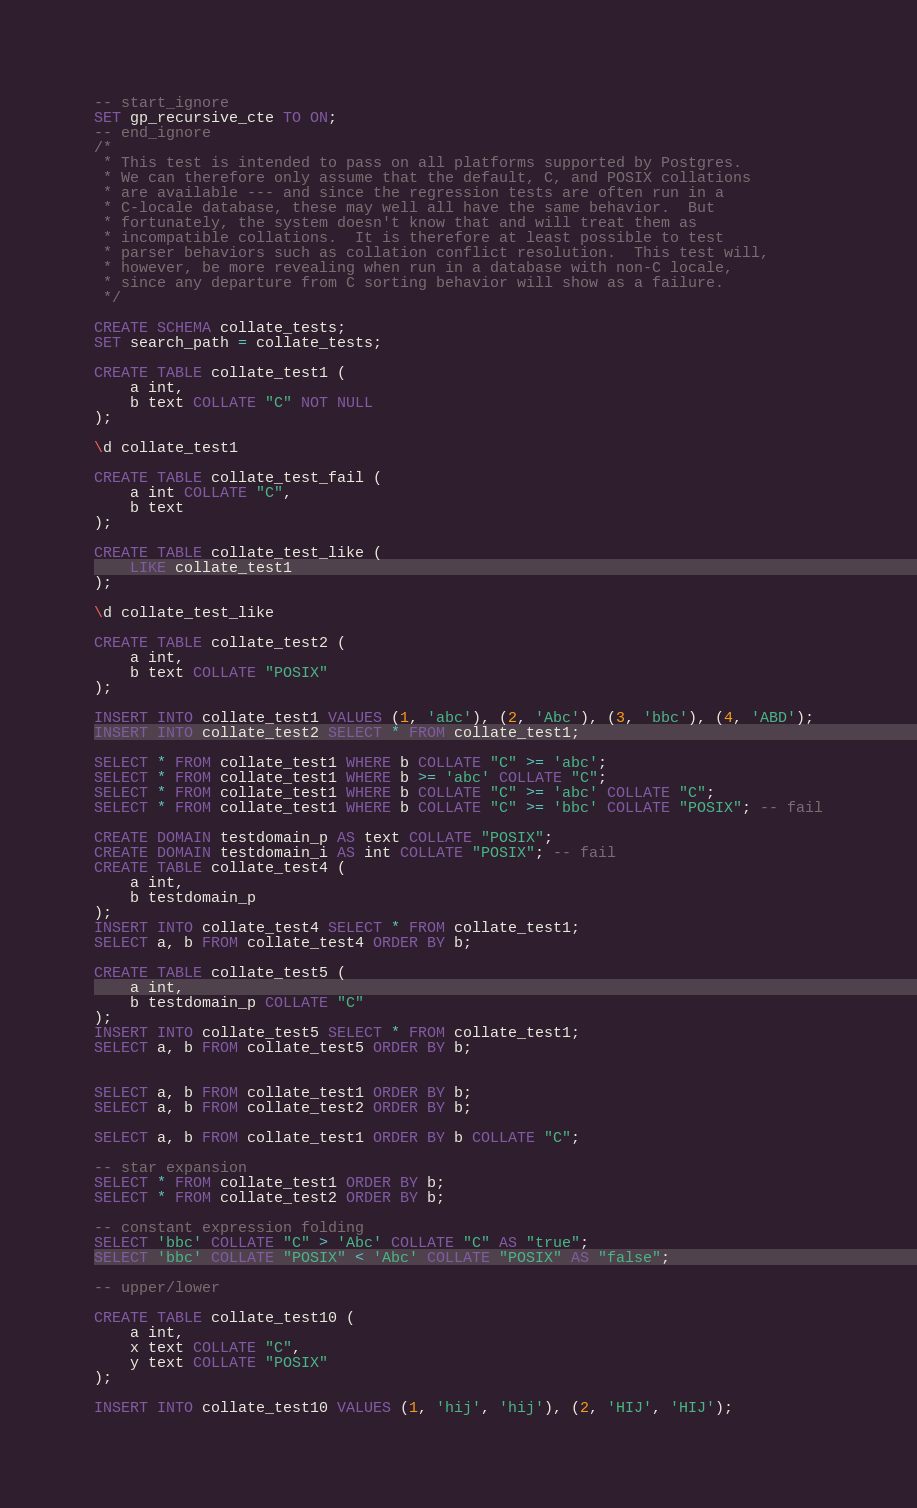<code> <loc_0><loc_0><loc_500><loc_500><_SQL_>-- start_ignore
SET gp_recursive_cte TO ON;
-- end_ignore
/*
 * This test is intended to pass on all platforms supported by Postgres.
 * We can therefore only assume that the default, C, and POSIX collations
 * are available --- and since the regression tests are often run in a
 * C-locale database, these may well all have the same behavior.  But
 * fortunately, the system doesn't know that and will treat them as
 * incompatible collations.  It is therefore at least possible to test
 * parser behaviors such as collation conflict resolution.  This test will,
 * however, be more revealing when run in a database with non-C locale,
 * since any departure from C sorting behavior will show as a failure.
 */

CREATE SCHEMA collate_tests;
SET search_path = collate_tests;

CREATE TABLE collate_test1 (
    a int,
    b text COLLATE "C" NOT NULL
);

\d collate_test1

CREATE TABLE collate_test_fail (
    a int COLLATE "C",
    b text
);

CREATE TABLE collate_test_like (
    LIKE collate_test1
);

\d collate_test_like

CREATE TABLE collate_test2 (
    a int,
    b text COLLATE "POSIX"
);

INSERT INTO collate_test1 VALUES (1, 'abc'), (2, 'Abc'), (3, 'bbc'), (4, 'ABD');
INSERT INTO collate_test2 SELECT * FROM collate_test1;

SELECT * FROM collate_test1 WHERE b COLLATE "C" >= 'abc';
SELECT * FROM collate_test1 WHERE b >= 'abc' COLLATE "C";
SELECT * FROM collate_test1 WHERE b COLLATE "C" >= 'abc' COLLATE "C";
SELECT * FROM collate_test1 WHERE b COLLATE "C" >= 'bbc' COLLATE "POSIX"; -- fail

CREATE DOMAIN testdomain_p AS text COLLATE "POSIX";
CREATE DOMAIN testdomain_i AS int COLLATE "POSIX"; -- fail
CREATE TABLE collate_test4 (
    a int,
    b testdomain_p
);
INSERT INTO collate_test4 SELECT * FROM collate_test1;
SELECT a, b FROM collate_test4 ORDER BY b;

CREATE TABLE collate_test5 (
    a int,
    b testdomain_p COLLATE "C"
);
INSERT INTO collate_test5 SELECT * FROM collate_test1;
SELECT a, b FROM collate_test5 ORDER BY b;


SELECT a, b FROM collate_test1 ORDER BY b;
SELECT a, b FROM collate_test2 ORDER BY b;

SELECT a, b FROM collate_test1 ORDER BY b COLLATE "C";

-- star expansion
SELECT * FROM collate_test1 ORDER BY b;
SELECT * FROM collate_test2 ORDER BY b;

-- constant expression folding
SELECT 'bbc' COLLATE "C" > 'Abc' COLLATE "C" AS "true";
SELECT 'bbc' COLLATE "POSIX" < 'Abc' COLLATE "POSIX" AS "false";

-- upper/lower

CREATE TABLE collate_test10 (
    a int,
    x text COLLATE "C",
    y text COLLATE "POSIX"
);

INSERT INTO collate_test10 VALUES (1, 'hij', 'hij'), (2, 'HIJ', 'HIJ');
</code> 